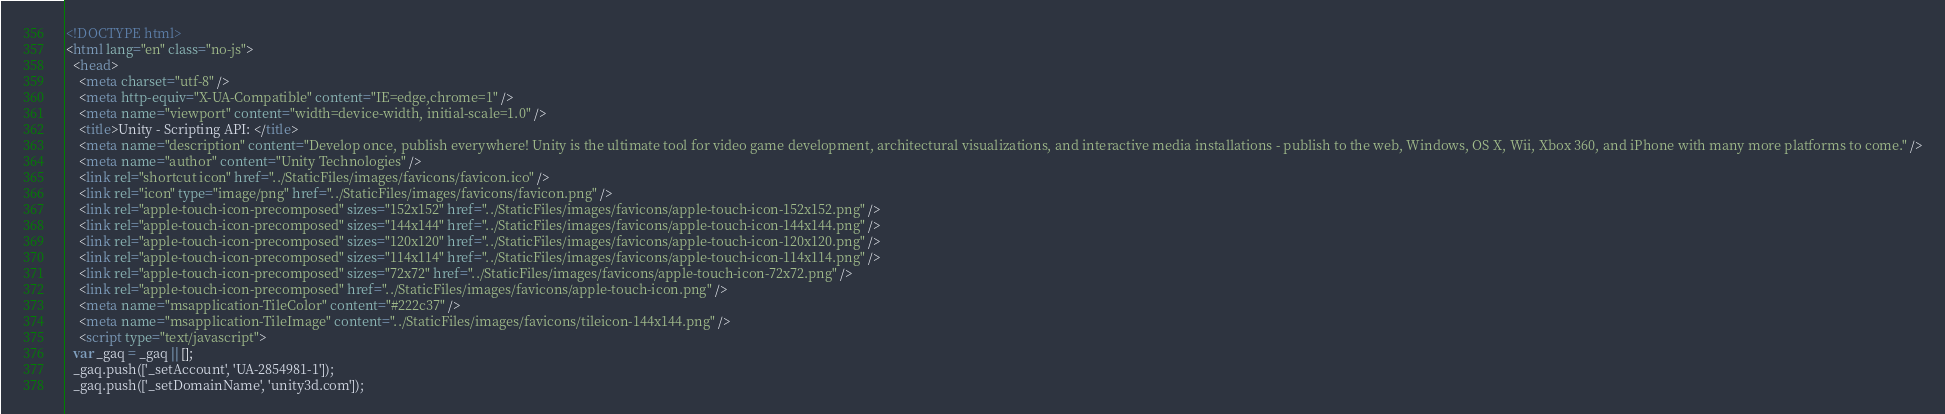Convert code to text. <code><loc_0><loc_0><loc_500><loc_500><_HTML_><!DOCTYPE html>
<html lang="en" class="no-js">
  <head>
    <meta charset="utf-8" />
    <meta http-equiv="X-UA-Compatible" content="IE=edge,chrome=1" />
    <meta name="viewport" content="width=device-width, initial-scale=1.0" />
    <title>Unity - Scripting API: </title>
    <meta name="description" content="Develop once, publish everywhere! Unity is the ultimate tool for video game development, architectural visualizations, and interactive media installations - publish to the web, Windows, OS X, Wii, Xbox 360, and iPhone with many more platforms to come." />
    <meta name="author" content="Unity Technologies" />
    <link rel="shortcut icon" href="../StaticFiles/images/favicons/favicon.ico" />
    <link rel="icon" type="image/png" href="../StaticFiles/images/favicons/favicon.png" />
    <link rel="apple-touch-icon-precomposed" sizes="152x152" href="../StaticFiles/images/favicons/apple-touch-icon-152x152.png" />
    <link rel="apple-touch-icon-precomposed" sizes="144x144" href="../StaticFiles/images/favicons/apple-touch-icon-144x144.png" />
    <link rel="apple-touch-icon-precomposed" sizes="120x120" href="../StaticFiles/images/favicons/apple-touch-icon-120x120.png" />
    <link rel="apple-touch-icon-precomposed" sizes="114x114" href="../StaticFiles/images/favicons/apple-touch-icon-114x114.png" />
    <link rel="apple-touch-icon-precomposed" sizes="72x72" href="../StaticFiles/images/favicons/apple-touch-icon-72x72.png" />
    <link rel="apple-touch-icon-precomposed" href="../StaticFiles/images/favicons/apple-touch-icon.png" />
    <meta name="msapplication-TileColor" content="#222c37" />
    <meta name="msapplication-TileImage" content="../StaticFiles/images/favicons/tileicon-144x144.png" />
    <script type="text/javascript">
  var _gaq = _gaq || [];
  _gaq.push(['_setAccount', 'UA-2854981-1']);
  _gaq.push(['_setDomainName', 'unity3d.com']);</code> 